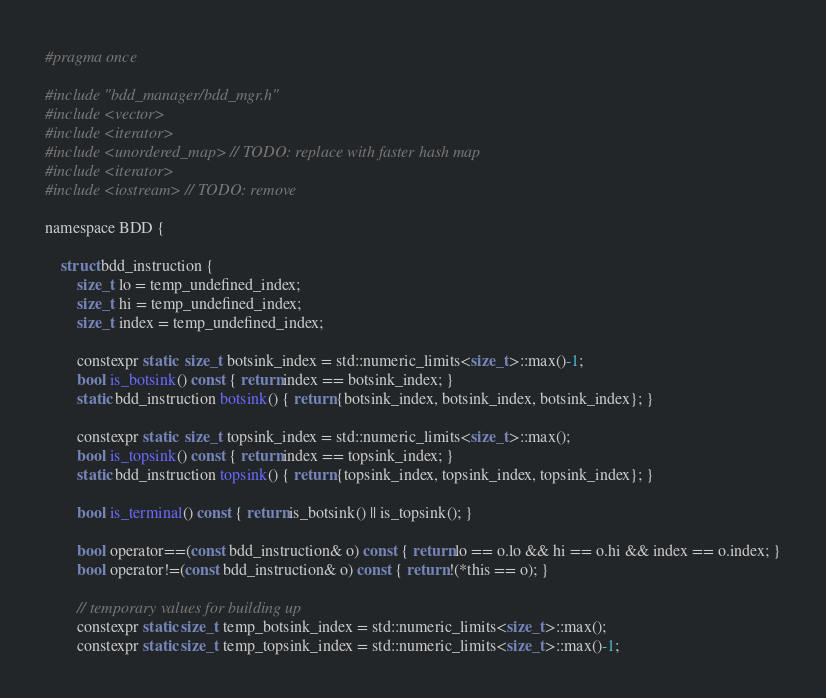<code> <loc_0><loc_0><loc_500><loc_500><_C_>#pragma once

#include "bdd_manager/bdd_mgr.h"
#include <vector>
#include <iterator>
#include <unordered_map> // TODO: replace with faster hash map
#include <iterator>
#include <iostream> // TODO: remove

namespace BDD {

    struct bdd_instruction {
        size_t lo = temp_undefined_index;
        size_t hi = temp_undefined_index;
        size_t index = temp_undefined_index;

        constexpr static  size_t botsink_index = std::numeric_limits<size_t>::max()-1;
        bool is_botsink() const { return index == botsink_index; }
        static bdd_instruction botsink() { return {botsink_index, botsink_index, botsink_index}; }

        constexpr static  size_t topsink_index = std::numeric_limits<size_t>::max();
        bool is_topsink() const { return index == topsink_index; }
        static bdd_instruction topsink() { return {topsink_index, topsink_index, topsink_index}; }

        bool is_terminal() const { return is_botsink() || is_topsink(); }

        bool operator==(const bdd_instruction& o) const { return lo == o.lo && hi == o.hi && index == o.index; }
        bool operator!=(const bdd_instruction& o) const { return !(*this == o); }

        // temporary values for building up
        constexpr static size_t temp_botsink_index = std::numeric_limits<size_t>::max();
        constexpr static size_t temp_topsink_index = std::numeric_limits<size_t>::max()-1;</code> 